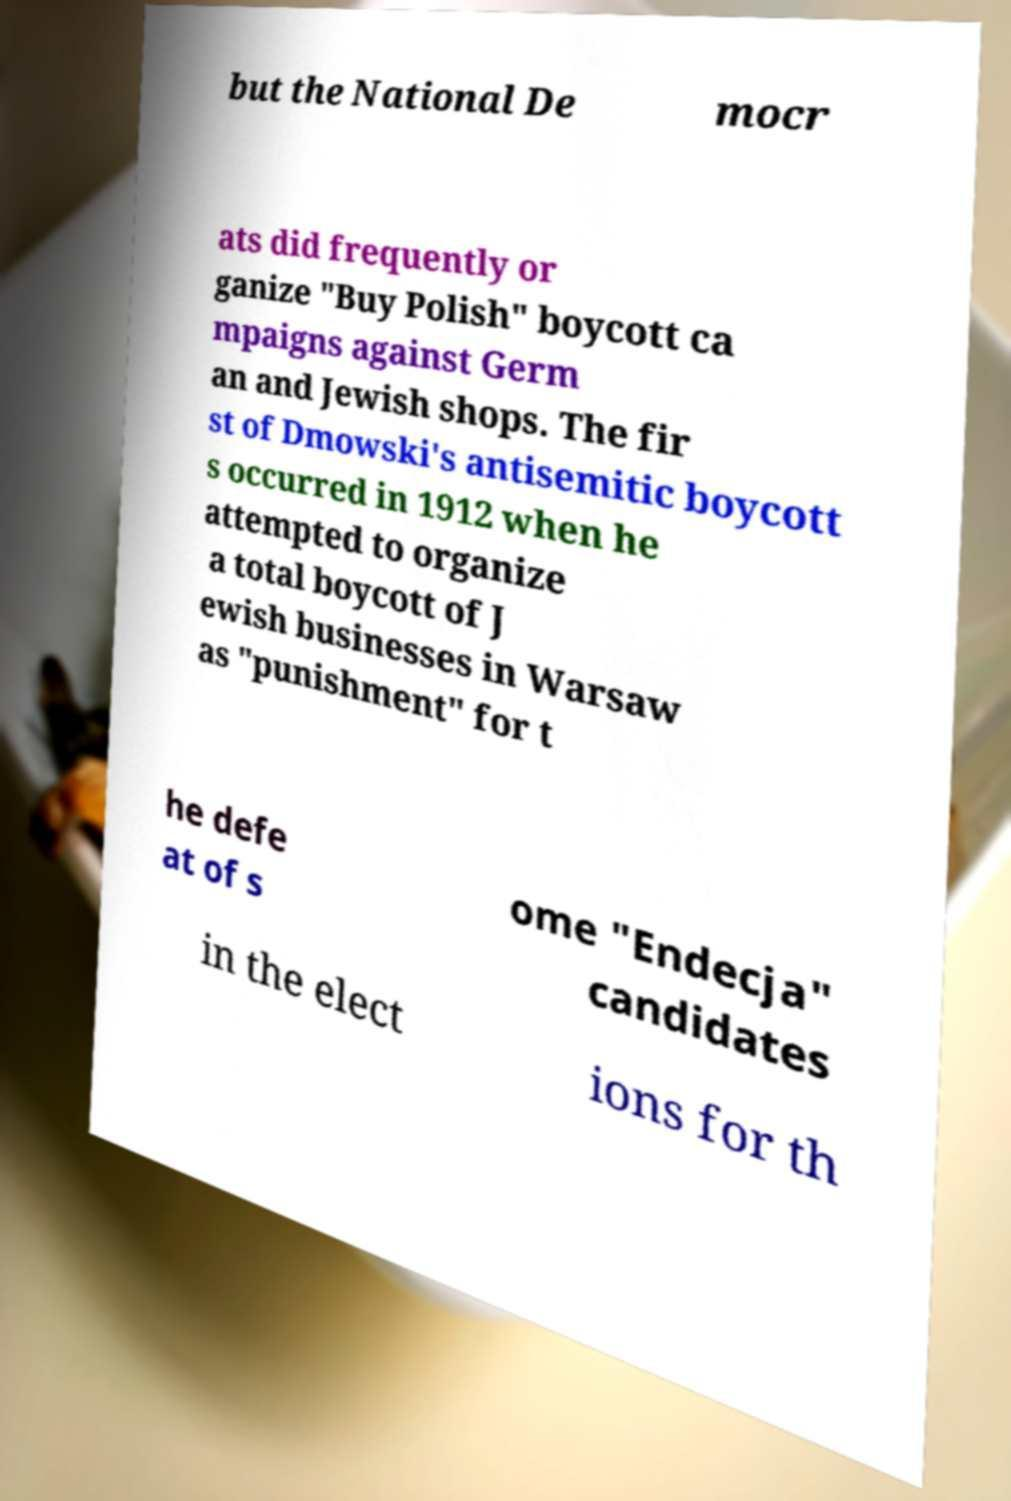There's text embedded in this image that I need extracted. Can you transcribe it verbatim? but the National De mocr ats did frequently or ganize "Buy Polish" boycott ca mpaigns against Germ an and Jewish shops. The fir st of Dmowski's antisemitic boycott s occurred in 1912 when he attempted to organize a total boycott of J ewish businesses in Warsaw as "punishment" for t he defe at of s ome "Endecja" candidates in the elect ions for th 